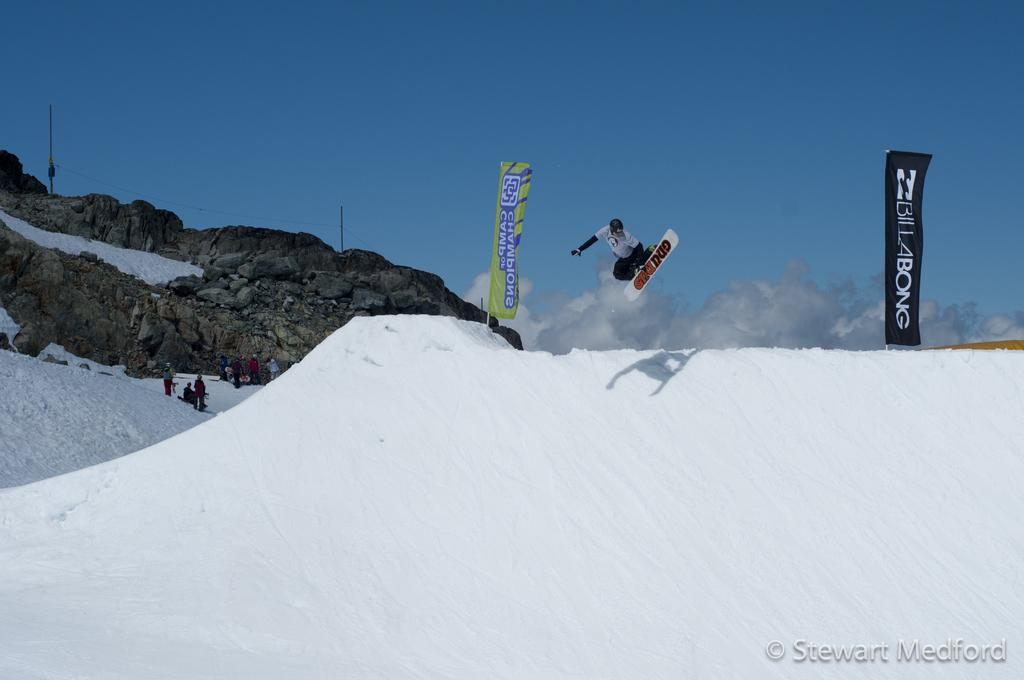What type of environment is shown in the image? The image depicts a snowy environment. What is the person holding and doing in the image? The person is holding a board and jumping in the image. Are there other people present in the image? Yes, there are other people present in the image. What can be seen in the background of the image? There are hills visible in the image. How many posters are there in the image? There are two posters in the image. What type of zephyr can be seen blowing through the frame in the image? There is no zephyr or frame present in the image; it depicts a snowy environment with people and hills. What is the person's level of fear while jumping with the board in the image? The image does not provide any information about the person's emotions or level of fear while jumping with the board. 